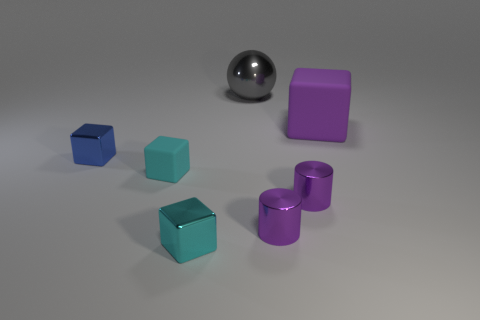Subtract all blue cubes. How many cubes are left? 3 Subtract all purple matte cubes. How many cubes are left? 3 Subtract all cylinders. How many objects are left? 5 Subtract all tiny metallic blocks. Subtract all tiny cyan objects. How many objects are left? 3 Add 3 purple rubber things. How many purple rubber things are left? 4 Add 1 small red matte cylinders. How many small red matte cylinders exist? 1 Add 2 big rubber things. How many objects exist? 9 Subtract 1 gray spheres. How many objects are left? 6 Subtract 1 cylinders. How many cylinders are left? 1 Subtract all blue cylinders. Subtract all yellow balls. How many cylinders are left? 2 